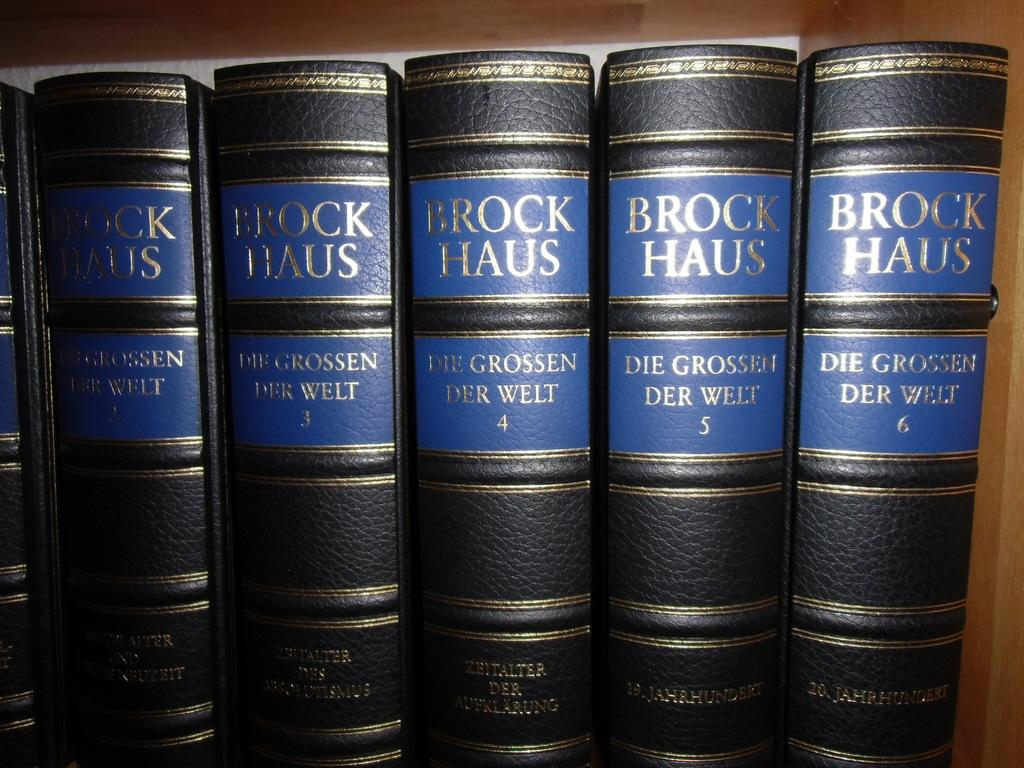Provide a one-sentence caption for the provided image. 6 books on a shelf with the name Brock Haus on it. 